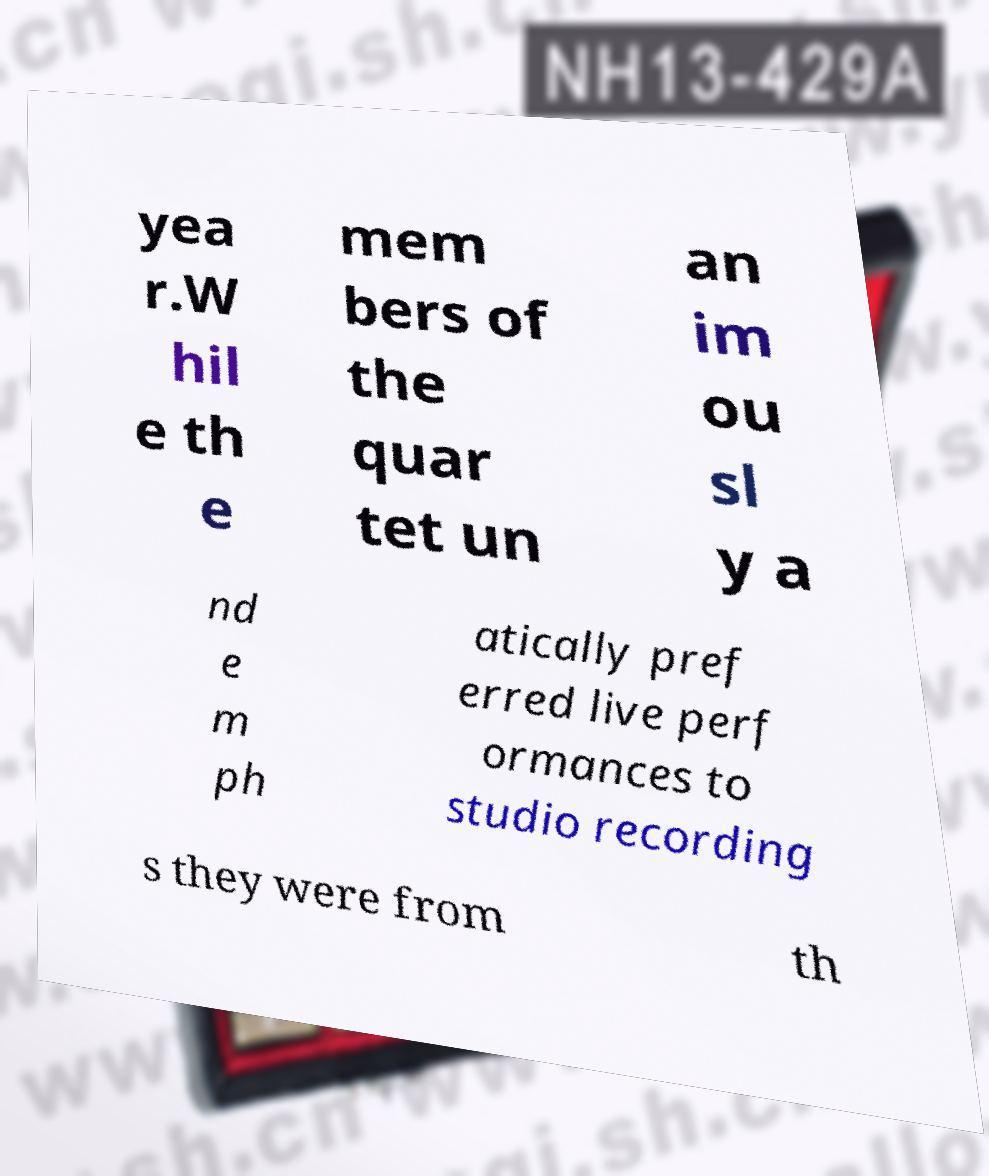Can you accurately transcribe the text from the provided image for me? yea r.W hil e th e mem bers of the quar tet un an im ou sl y a nd e m ph atically pref erred live perf ormances to studio recording s they were from th 